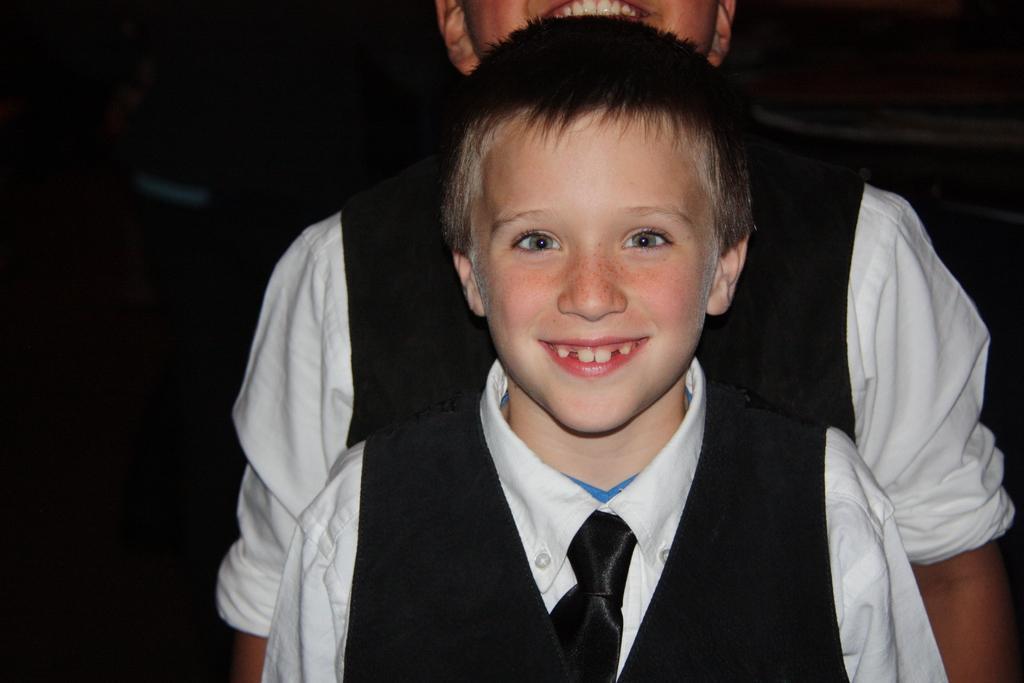Please provide a concise description of this image. In the image there is a boy in the foreground and behind him there is another boy. 